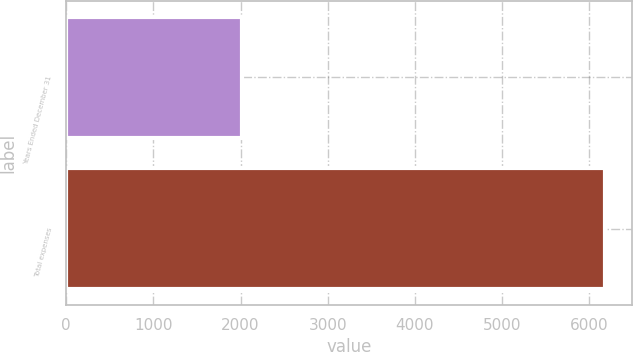<chart> <loc_0><loc_0><loc_500><loc_500><bar_chart><fcel>Years Ended December 31<fcel>Total expenses<nl><fcel>2013<fcel>6176<nl></chart> 